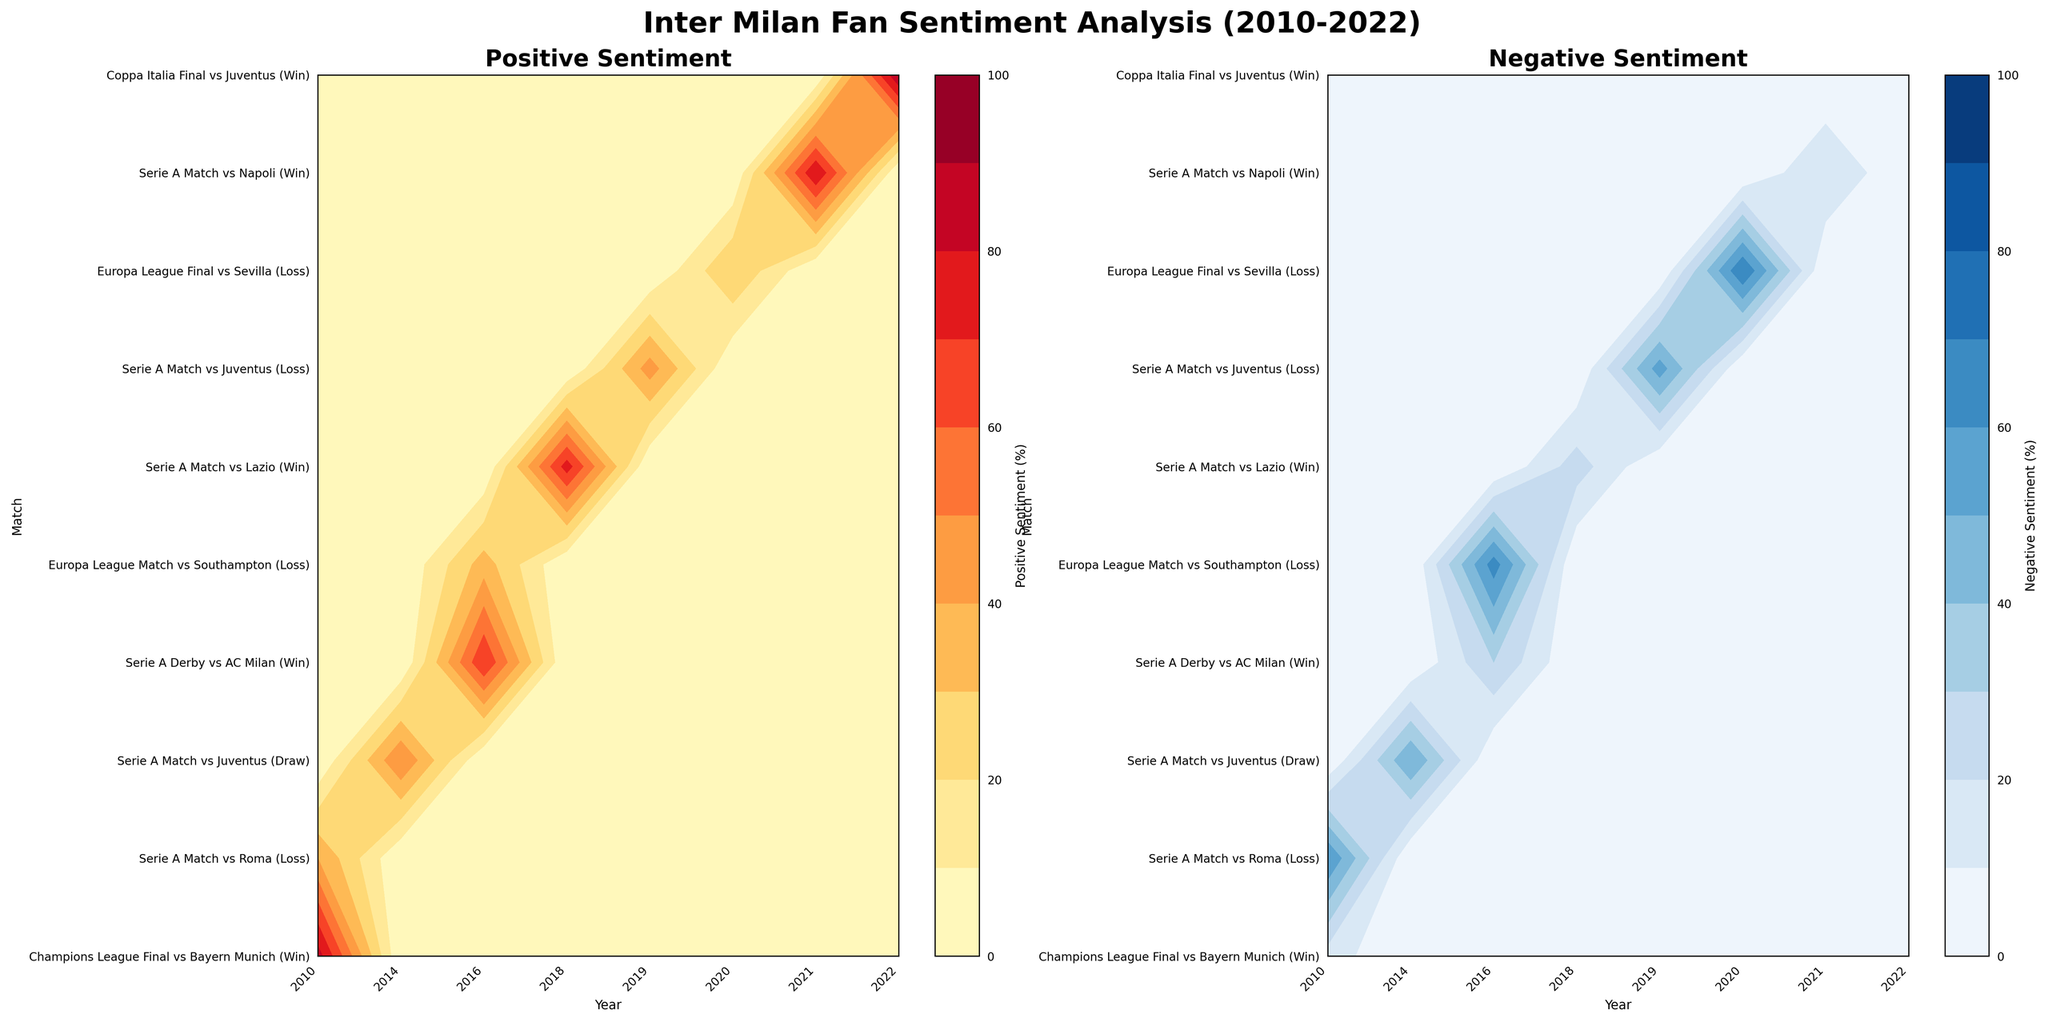What is the title of the first subplot? The title of the first subplot is mentioned at the top of the left-hand contour plot. It is labeled clearly to specify the type of sentiment being displayed.
Answer: Positive Sentiment How many years are represented in the x-axis labels? Counting the unique x-axis tick labels will reveal the total number of years represented. The x-axis covers data from 2010 to 2022.
Answer: 10 What match had the highest positive sentiment? Look at the color intensity in the first subplot. The match with the highest positive sentiment will align with the darkest color, indicating higher values.
Answer: Coppa Italia Final vs Juventus (2022) Which year had the highest negative sentiment for a match against Juventus? Focus on the second subplot and look for the highest intensity color corresponding to negative sentiments for Juventus matches. Check the year labels on the x-axis.
Answer: 2020 What year had multiple matches with significantly different sentiment values? Identify years where matches show a noticeable contrast between the first and second subplots in terms of color intensity for positive and negative sentiments.
Answer: 2016 In which year did fans have the most balanced sentiment for a Serie A match against Juventus? Look for even color distribution (similar intensities) in both subplots for the Serie A match vs Juventus across the different years.
Answer: 2014 What is the negative sentiment percentage for the Champions League Final vs Bayern Munich in 2010? Locate the match and year on the second subplot. Read off the value indicated by the color intensity.
Answer: 15% Compare the positive sentiment for Serie A matches vs Napoli. Which year had a higher positive sentiment? Check the first subplot for the year labels and match the corresponding color intensities for Serie A vs Napoli.
Answer: 2021 Which match in the year 2019 had the highest negative sentiment? Look at the year 2019 and compare color intensities within that year in the second subplot to determine the match with the highest negative sentiment.
Answer: Serie A Match vs Juventus Is the trend of fan sentiment generally positive or negative in Europa League matches over the years? Observe the color intensity for Europa League matches across different years in both subplots. Compare if the trend shows darker colors in the first subplot (positive) or the second subplot (negative).
Answer: Negative 